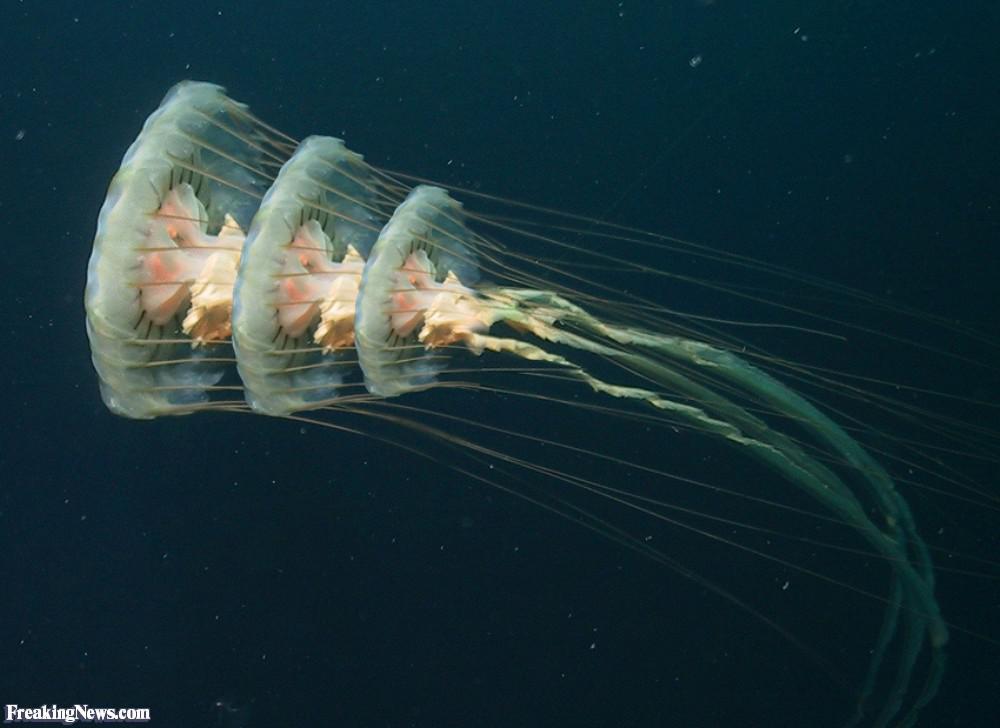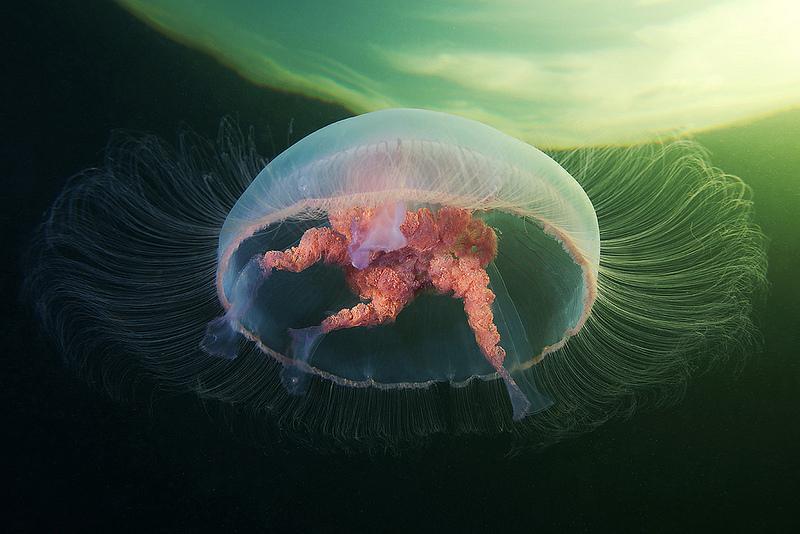The first image is the image on the left, the second image is the image on the right. Assess this claim about the two images: "At least one image shows a jellyfish with a folded appearance and no tendrils trailing from it.". Correct or not? Answer yes or no. No. The first image is the image on the left, the second image is the image on the right. Assess this claim about the two images: "The sea creature in the image on the right looks like a cross between a clownfish and a jellyfish, with its bright orange body and white blotches.". Correct or not? Answer yes or no. No. 